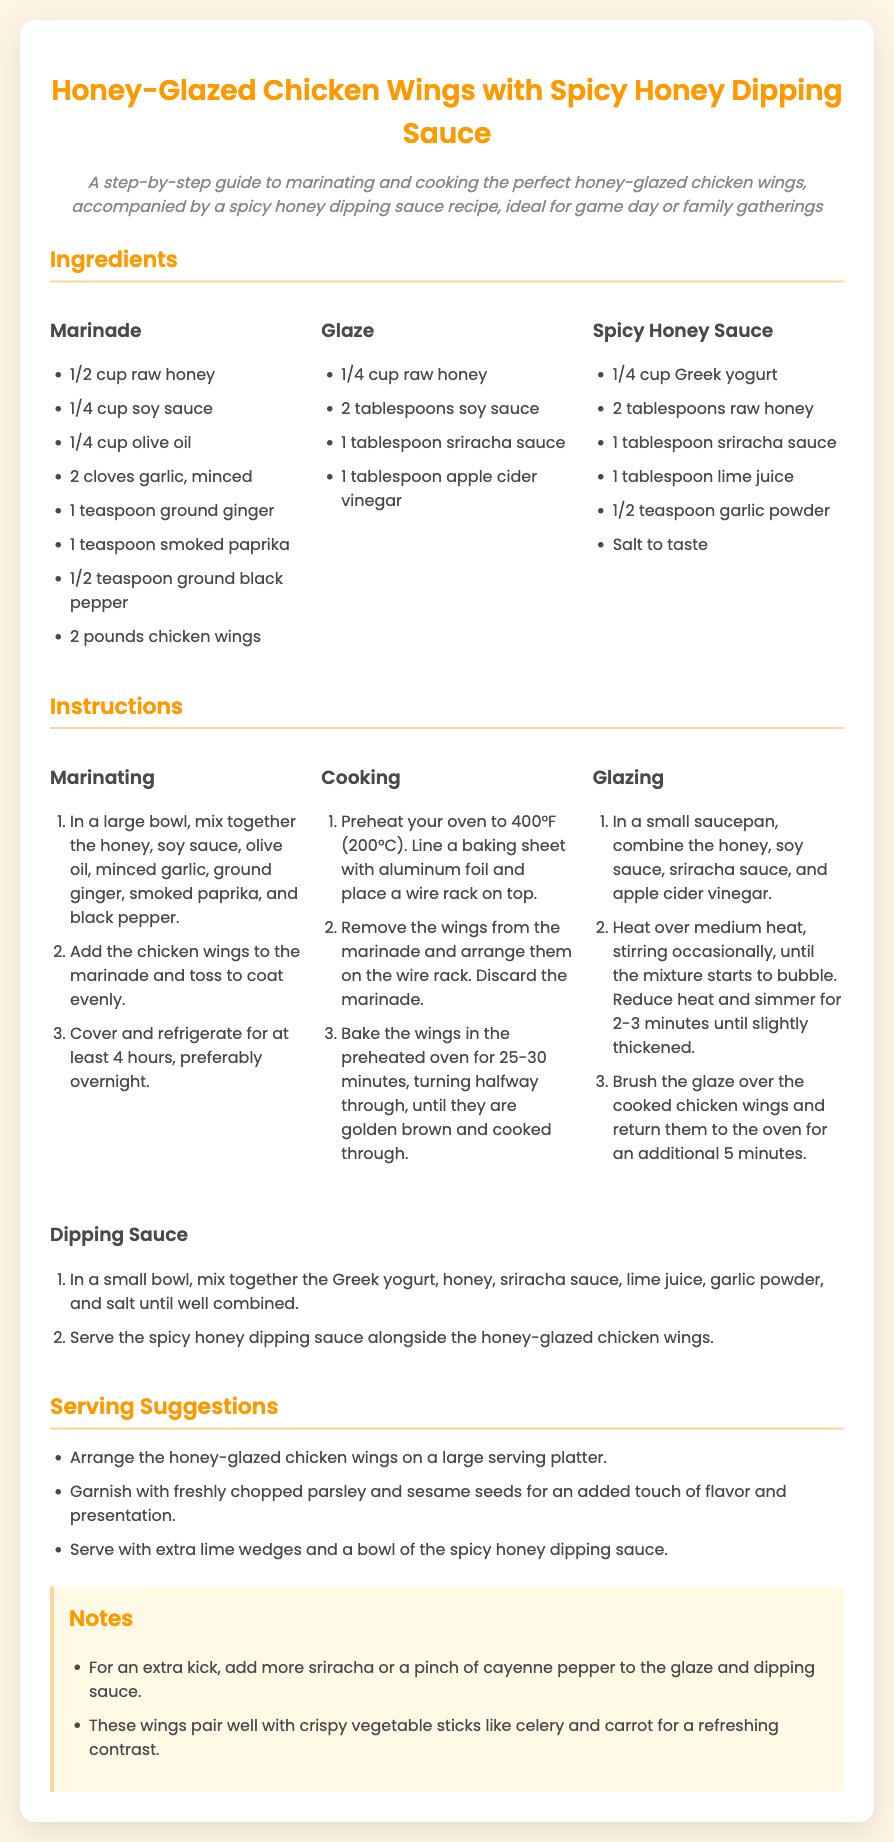what are the main ingredients for the marinade? The main ingredients for the marinade are listed under the ingredient group "Marinade." They include honey, soy sauce, olive oil, garlic, ginger, paprika, black pepper, and chicken wings.
Answer: honey, soy sauce, olive oil, garlic, ginger, paprika, black pepper, chicken wings how long should the wings marinate? The document states that the wings should be marinated for at least 4 hours, preferably overnight.
Answer: at least 4 hours what is the baking temperature for the chicken wings? The recipe specifies to preheat the oven to 400°F (200°C) before baking the wings.
Answer: 400°F (200°C) how many pounds of chicken wings are required? The ingredient list indicates that 2 pounds of chicken wings are needed for this recipe.
Answer: 2 pounds what adds spiciness to the honey glaze? The spiciness to the honey glaze comes from the sriracha sauce, which is one of the ingredients listed.
Answer: sriracha sauce what is a suggested garnish for serving? The document recommends garnishing the wings with freshly chopped parsley and sesame seeds for added flavor and presentation.
Answer: freshly chopped parsley and sesame seeds how many servings does the recipe imply? The document does not specify an exact number of servings, but it is implied that it serves a group, suitable for game day or family gatherings.
Answer: group servings what is included in the spicy honey sauce? The ingredients for the spicy honey sauce are listed under the corresponding ingredient group, which includes Greek yogurt, honey, sriracha, lime juice, garlic powder, and salt.
Answer: Greek yogurt, honey, sriracha, lime juice, garlic powder, salt where can the spicy honey dipping sauce be served? The instructions mention to serve the spicy honey dipping sauce alongside the honey-glazed chicken wings, indicating its purpose.
Answer: alongside the honey-glazed chicken wings 